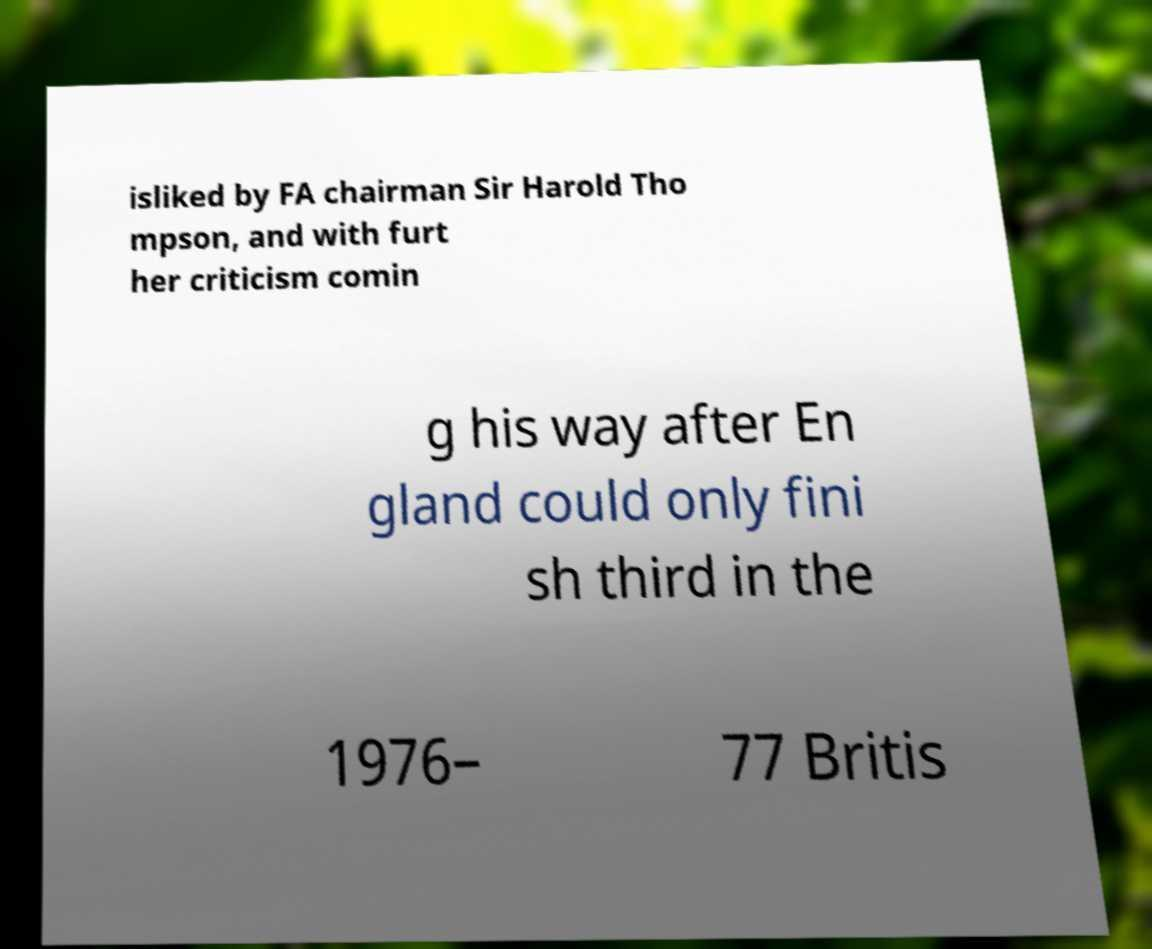Can you read and provide the text displayed in the image?This photo seems to have some interesting text. Can you extract and type it out for me? isliked by FA chairman Sir Harold Tho mpson, and with furt her criticism comin g his way after En gland could only fini sh third in the 1976– 77 Britis 